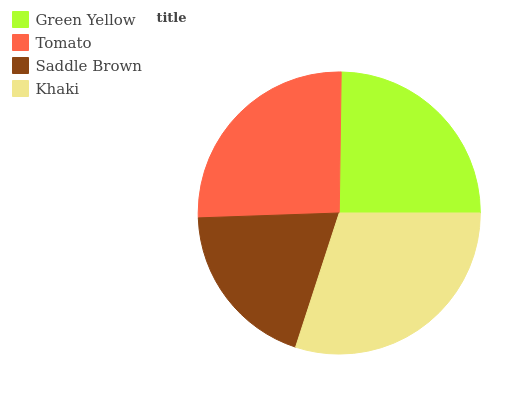Is Saddle Brown the minimum?
Answer yes or no. Yes. Is Khaki the maximum?
Answer yes or no. Yes. Is Tomato the minimum?
Answer yes or no. No. Is Tomato the maximum?
Answer yes or no. No. Is Tomato greater than Green Yellow?
Answer yes or no. Yes. Is Green Yellow less than Tomato?
Answer yes or no. Yes. Is Green Yellow greater than Tomato?
Answer yes or no. No. Is Tomato less than Green Yellow?
Answer yes or no. No. Is Tomato the high median?
Answer yes or no. Yes. Is Green Yellow the low median?
Answer yes or no. Yes. Is Green Yellow the high median?
Answer yes or no. No. Is Saddle Brown the low median?
Answer yes or no. No. 